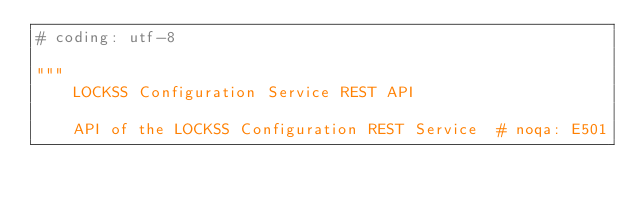Convert code to text. <code><loc_0><loc_0><loc_500><loc_500><_Python_># coding: utf-8

"""
    LOCKSS Configuration Service REST API

    API of the LOCKSS Configuration REST Service  # noqa: E501
</code> 